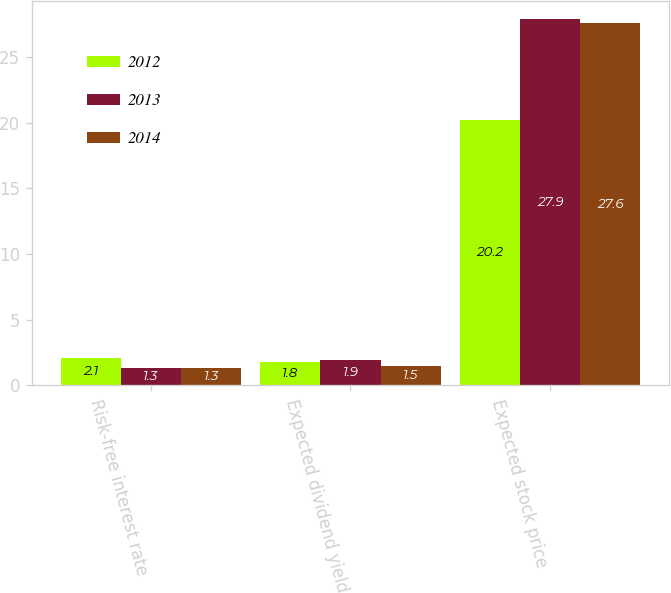<chart> <loc_0><loc_0><loc_500><loc_500><stacked_bar_chart><ecel><fcel>Risk-free interest rate<fcel>Expected dividend yield<fcel>Expected stock price<nl><fcel>2012<fcel>2.1<fcel>1.8<fcel>20.2<nl><fcel>2013<fcel>1.3<fcel>1.9<fcel>27.9<nl><fcel>2014<fcel>1.3<fcel>1.5<fcel>27.6<nl></chart> 